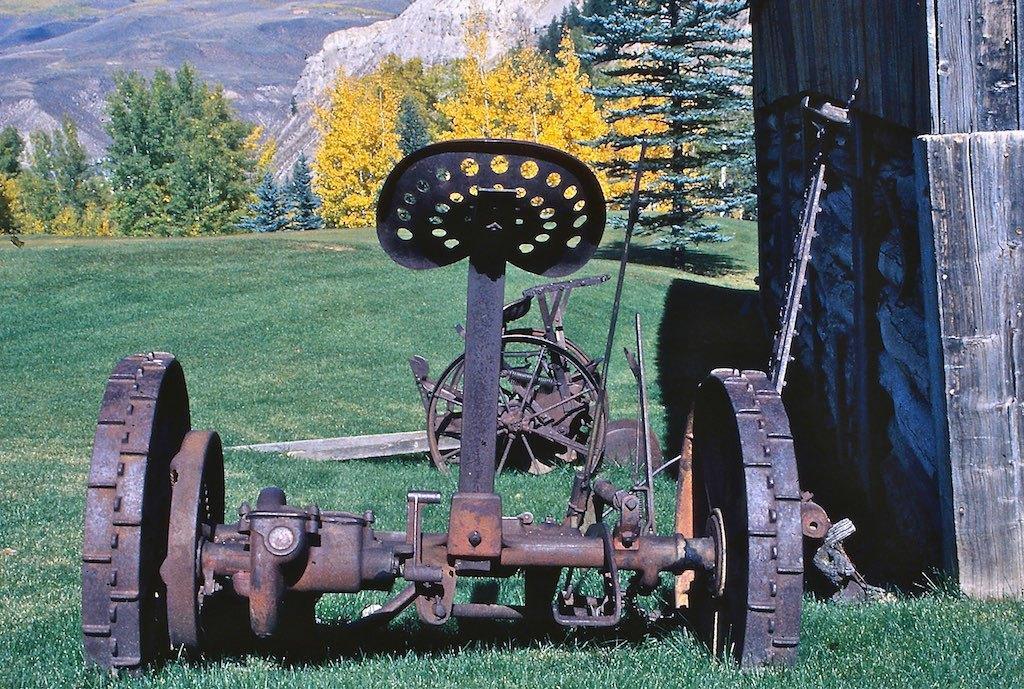How would you summarize this image in a sentence or two? Here we can see a vehicle and a wall. This is grass. In the background we can see trees and a mountain. 